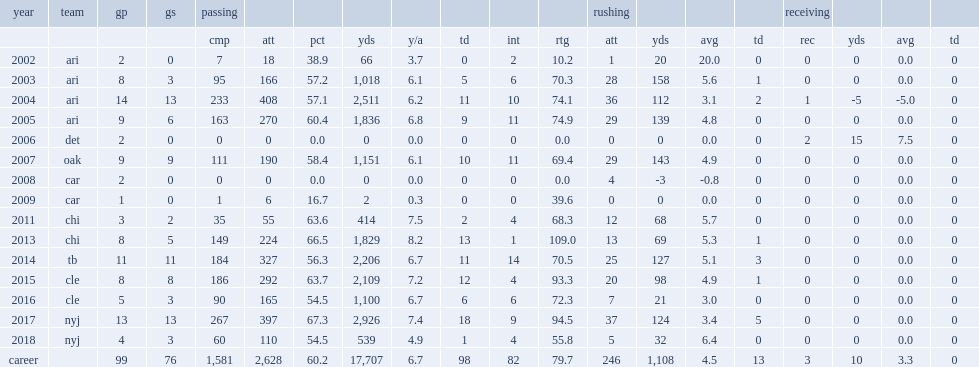In 2005, what is averaged passing yards for josh mccown? 1836.0. 